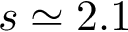Convert formula to latex. <formula><loc_0><loc_0><loc_500><loc_500>s \simeq 2 . 1</formula> 